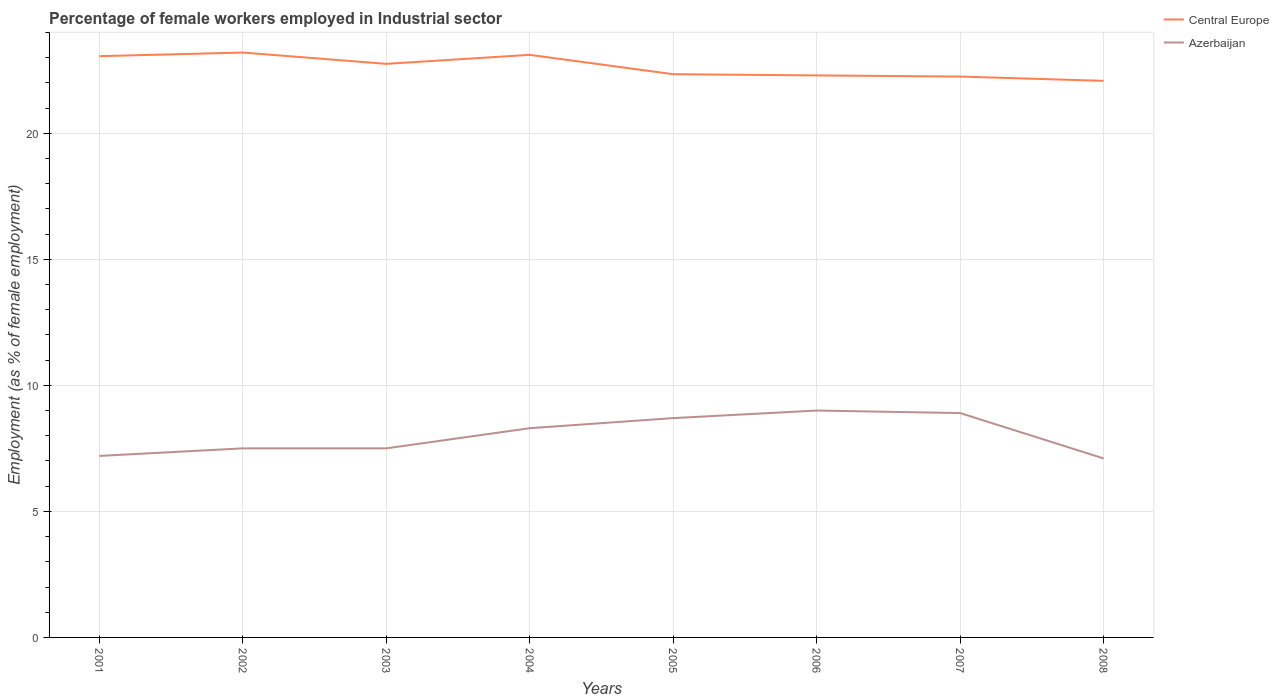How many different coloured lines are there?
Make the answer very short. 2. Does the line corresponding to Azerbaijan intersect with the line corresponding to Central Europe?
Keep it short and to the point. No. Is the number of lines equal to the number of legend labels?
Your answer should be compact. Yes. Across all years, what is the maximum percentage of females employed in Industrial sector in Azerbaijan?
Your response must be concise. 7.1. In which year was the percentage of females employed in Industrial sector in Central Europe maximum?
Offer a very short reply. 2008. What is the total percentage of females employed in Industrial sector in Central Europe in the graph?
Your answer should be very brief. 1.12. What is the difference between the highest and the second highest percentage of females employed in Industrial sector in Azerbaijan?
Offer a terse response. 1.9. What is the difference between the highest and the lowest percentage of females employed in Industrial sector in Central Europe?
Make the answer very short. 4. Is the percentage of females employed in Industrial sector in Azerbaijan strictly greater than the percentage of females employed in Industrial sector in Central Europe over the years?
Provide a succinct answer. Yes. Does the graph contain any zero values?
Offer a terse response. No. Does the graph contain grids?
Your response must be concise. Yes. Where does the legend appear in the graph?
Offer a very short reply. Top right. What is the title of the graph?
Offer a terse response. Percentage of female workers employed in Industrial sector. Does "Egypt, Arab Rep." appear as one of the legend labels in the graph?
Keep it short and to the point. No. What is the label or title of the X-axis?
Provide a short and direct response. Years. What is the label or title of the Y-axis?
Offer a very short reply. Employment (as % of female employment). What is the Employment (as % of female employment) in Central Europe in 2001?
Offer a very short reply. 23.06. What is the Employment (as % of female employment) in Azerbaijan in 2001?
Offer a very short reply. 7.2. What is the Employment (as % of female employment) of Central Europe in 2002?
Offer a very short reply. 23.2. What is the Employment (as % of female employment) of Azerbaijan in 2002?
Provide a short and direct response. 7.5. What is the Employment (as % of female employment) of Central Europe in 2003?
Make the answer very short. 22.75. What is the Employment (as % of female employment) in Central Europe in 2004?
Keep it short and to the point. 23.11. What is the Employment (as % of female employment) in Azerbaijan in 2004?
Make the answer very short. 8.3. What is the Employment (as % of female employment) in Central Europe in 2005?
Your answer should be very brief. 22.34. What is the Employment (as % of female employment) of Azerbaijan in 2005?
Your answer should be compact. 8.7. What is the Employment (as % of female employment) of Central Europe in 2006?
Your answer should be compact. 22.29. What is the Employment (as % of female employment) in Azerbaijan in 2006?
Give a very brief answer. 9. What is the Employment (as % of female employment) of Central Europe in 2007?
Provide a short and direct response. 22.25. What is the Employment (as % of female employment) of Azerbaijan in 2007?
Give a very brief answer. 8.9. What is the Employment (as % of female employment) of Central Europe in 2008?
Offer a very short reply. 22.08. What is the Employment (as % of female employment) in Azerbaijan in 2008?
Keep it short and to the point. 7.1. Across all years, what is the maximum Employment (as % of female employment) in Central Europe?
Offer a very short reply. 23.2. Across all years, what is the maximum Employment (as % of female employment) of Azerbaijan?
Provide a succinct answer. 9. Across all years, what is the minimum Employment (as % of female employment) of Central Europe?
Make the answer very short. 22.08. Across all years, what is the minimum Employment (as % of female employment) of Azerbaijan?
Offer a terse response. 7.1. What is the total Employment (as % of female employment) in Central Europe in the graph?
Keep it short and to the point. 181.08. What is the total Employment (as % of female employment) of Azerbaijan in the graph?
Offer a very short reply. 64.2. What is the difference between the Employment (as % of female employment) in Central Europe in 2001 and that in 2002?
Offer a very short reply. -0.14. What is the difference between the Employment (as % of female employment) of Central Europe in 2001 and that in 2003?
Provide a short and direct response. 0.3. What is the difference between the Employment (as % of female employment) of Central Europe in 2001 and that in 2004?
Offer a very short reply. -0.05. What is the difference between the Employment (as % of female employment) in Azerbaijan in 2001 and that in 2004?
Provide a short and direct response. -1.1. What is the difference between the Employment (as % of female employment) of Central Europe in 2001 and that in 2005?
Provide a succinct answer. 0.72. What is the difference between the Employment (as % of female employment) in Azerbaijan in 2001 and that in 2005?
Your answer should be very brief. -1.5. What is the difference between the Employment (as % of female employment) in Central Europe in 2001 and that in 2006?
Your answer should be very brief. 0.76. What is the difference between the Employment (as % of female employment) of Central Europe in 2001 and that in 2007?
Give a very brief answer. 0.81. What is the difference between the Employment (as % of female employment) in Azerbaijan in 2001 and that in 2007?
Make the answer very short. -1.7. What is the difference between the Employment (as % of female employment) in Azerbaijan in 2001 and that in 2008?
Give a very brief answer. 0.1. What is the difference between the Employment (as % of female employment) in Central Europe in 2002 and that in 2003?
Offer a very short reply. 0.45. What is the difference between the Employment (as % of female employment) in Azerbaijan in 2002 and that in 2003?
Give a very brief answer. 0. What is the difference between the Employment (as % of female employment) in Central Europe in 2002 and that in 2004?
Give a very brief answer. 0.09. What is the difference between the Employment (as % of female employment) of Azerbaijan in 2002 and that in 2004?
Offer a very short reply. -0.8. What is the difference between the Employment (as % of female employment) in Central Europe in 2002 and that in 2005?
Ensure brevity in your answer.  0.86. What is the difference between the Employment (as % of female employment) of Azerbaijan in 2002 and that in 2005?
Offer a terse response. -1.2. What is the difference between the Employment (as % of female employment) in Central Europe in 2002 and that in 2006?
Provide a short and direct response. 0.91. What is the difference between the Employment (as % of female employment) in Azerbaijan in 2002 and that in 2006?
Offer a very short reply. -1.5. What is the difference between the Employment (as % of female employment) in Central Europe in 2002 and that in 2007?
Provide a short and direct response. 0.95. What is the difference between the Employment (as % of female employment) in Central Europe in 2002 and that in 2008?
Your response must be concise. 1.12. What is the difference between the Employment (as % of female employment) in Central Europe in 2003 and that in 2004?
Your answer should be compact. -0.36. What is the difference between the Employment (as % of female employment) in Azerbaijan in 2003 and that in 2004?
Your answer should be compact. -0.8. What is the difference between the Employment (as % of female employment) of Central Europe in 2003 and that in 2005?
Provide a succinct answer. 0.41. What is the difference between the Employment (as % of female employment) in Azerbaijan in 2003 and that in 2005?
Provide a short and direct response. -1.2. What is the difference between the Employment (as % of female employment) in Central Europe in 2003 and that in 2006?
Provide a short and direct response. 0.46. What is the difference between the Employment (as % of female employment) of Azerbaijan in 2003 and that in 2006?
Provide a succinct answer. -1.5. What is the difference between the Employment (as % of female employment) in Central Europe in 2003 and that in 2007?
Provide a short and direct response. 0.5. What is the difference between the Employment (as % of female employment) of Azerbaijan in 2003 and that in 2007?
Your answer should be very brief. -1.4. What is the difference between the Employment (as % of female employment) in Central Europe in 2003 and that in 2008?
Offer a terse response. 0.68. What is the difference between the Employment (as % of female employment) of Central Europe in 2004 and that in 2005?
Offer a terse response. 0.77. What is the difference between the Employment (as % of female employment) of Central Europe in 2004 and that in 2006?
Provide a succinct answer. 0.82. What is the difference between the Employment (as % of female employment) of Central Europe in 2004 and that in 2007?
Your answer should be very brief. 0.86. What is the difference between the Employment (as % of female employment) of Azerbaijan in 2004 and that in 2007?
Keep it short and to the point. -0.6. What is the difference between the Employment (as % of female employment) in Central Europe in 2004 and that in 2008?
Your response must be concise. 1.03. What is the difference between the Employment (as % of female employment) of Central Europe in 2005 and that in 2006?
Ensure brevity in your answer.  0.05. What is the difference between the Employment (as % of female employment) of Central Europe in 2005 and that in 2007?
Make the answer very short. 0.09. What is the difference between the Employment (as % of female employment) in Azerbaijan in 2005 and that in 2007?
Give a very brief answer. -0.2. What is the difference between the Employment (as % of female employment) of Central Europe in 2005 and that in 2008?
Give a very brief answer. 0.26. What is the difference between the Employment (as % of female employment) in Central Europe in 2006 and that in 2007?
Your answer should be compact. 0.05. What is the difference between the Employment (as % of female employment) in Central Europe in 2006 and that in 2008?
Give a very brief answer. 0.22. What is the difference between the Employment (as % of female employment) of Central Europe in 2007 and that in 2008?
Give a very brief answer. 0.17. What is the difference between the Employment (as % of female employment) in Azerbaijan in 2007 and that in 2008?
Provide a succinct answer. 1.8. What is the difference between the Employment (as % of female employment) in Central Europe in 2001 and the Employment (as % of female employment) in Azerbaijan in 2002?
Your answer should be very brief. 15.56. What is the difference between the Employment (as % of female employment) in Central Europe in 2001 and the Employment (as % of female employment) in Azerbaijan in 2003?
Keep it short and to the point. 15.56. What is the difference between the Employment (as % of female employment) in Central Europe in 2001 and the Employment (as % of female employment) in Azerbaijan in 2004?
Make the answer very short. 14.76. What is the difference between the Employment (as % of female employment) of Central Europe in 2001 and the Employment (as % of female employment) of Azerbaijan in 2005?
Provide a short and direct response. 14.36. What is the difference between the Employment (as % of female employment) in Central Europe in 2001 and the Employment (as % of female employment) in Azerbaijan in 2006?
Keep it short and to the point. 14.06. What is the difference between the Employment (as % of female employment) in Central Europe in 2001 and the Employment (as % of female employment) in Azerbaijan in 2007?
Make the answer very short. 14.16. What is the difference between the Employment (as % of female employment) of Central Europe in 2001 and the Employment (as % of female employment) of Azerbaijan in 2008?
Keep it short and to the point. 15.96. What is the difference between the Employment (as % of female employment) of Central Europe in 2002 and the Employment (as % of female employment) of Azerbaijan in 2003?
Your answer should be very brief. 15.7. What is the difference between the Employment (as % of female employment) of Central Europe in 2002 and the Employment (as % of female employment) of Azerbaijan in 2004?
Keep it short and to the point. 14.9. What is the difference between the Employment (as % of female employment) of Central Europe in 2002 and the Employment (as % of female employment) of Azerbaijan in 2005?
Offer a very short reply. 14.5. What is the difference between the Employment (as % of female employment) in Central Europe in 2002 and the Employment (as % of female employment) in Azerbaijan in 2006?
Provide a short and direct response. 14.2. What is the difference between the Employment (as % of female employment) in Central Europe in 2002 and the Employment (as % of female employment) in Azerbaijan in 2007?
Provide a succinct answer. 14.3. What is the difference between the Employment (as % of female employment) of Central Europe in 2002 and the Employment (as % of female employment) of Azerbaijan in 2008?
Your answer should be very brief. 16.1. What is the difference between the Employment (as % of female employment) in Central Europe in 2003 and the Employment (as % of female employment) in Azerbaijan in 2004?
Provide a succinct answer. 14.45. What is the difference between the Employment (as % of female employment) of Central Europe in 2003 and the Employment (as % of female employment) of Azerbaijan in 2005?
Offer a very short reply. 14.05. What is the difference between the Employment (as % of female employment) of Central Europe in 2003 and the Employment (as % of female employment) of Azerbaijan in 2006?
Make the answer very short. 13.75. What is the difference between the Employment (as % of female employment) of Central Europe in 2003 and the Employment (as % of female employment) of Azerbaijan in 2007?
Your answer should be compact. 13.85. What is the difference between the Employment (as % of female employment) in Central Europe in 2003 and the Employment (as % of female employment) in Azerbaijan in 2008?
Your answer should be compact. 15.65. What is the difference between the Employment (as % of female employment) in Central Europe in 2004 and the Employment (as % of female employment) in Azerbaijan in 2005?
Provide a succinct answer. 14.41. What is the difference between the Employment (as % of female employment) in Central Europe in 2004 and the Employment (as % of female employment) in Azerbaijan in 2006?
Your response must be concise. 14.11. What is the difference between the Employment (as % of female employment) of Central Europe in 2004 and the Employment (as % of female employment) of Azerbaijan in 2007?
Your answer should be compact. 14.21. What is the difference between the Employment (as % of female employment) in Central Europe in 2004 and the Employment (as % of female employment) in Azerbaijan in 2008?
Offer a very short reply. 16.01. What is the difference between the Employment (as % of female employment) of Central Europe in 2005 and the Employment (as % of female employment) of Azerbaijan in 2006?
Provide a short and direct response. 13.34. What is the difference between the Employment (as % of female employment) in Central Europe in 2005 and the Employment (as % of female employment) in Azerbaijan in 2007?
Your response must be concise. 13.44. What is the difference between the Employment (as % of female employment) of Central Europe in 2005 and the Employment (as % of female employment) of Azerbaijan in 2008?
Keep it short and to the point. 15.24. What is the difference between the Employment (as % of female employment) in Central Europe in 2006 and the Employment (as % of female employment) in Azerbaijan in 2007?
Keep it short and to the point. 13.39. What is the difference between the Employment (as % of female employment) in Central Europe in 2006 and the Employment (as % of female employment) in Azerbaijan in 2008?
Offer a terse response. 15.19. What is the difference between the Employment (as % of female employment) in Central Europe in 2007 and the Employment (as % of female employment) in Azerbaijan in 2008?
Offer a very short reply. 15.15. What is the average Employment (as % of female employment) of Central Europe per year?
Provide a succinct answer. 22.64. What is the average Employment (as % of female employment) of Azerbaijan per year?
Keep it short and to the point. 8.03. In the year 2001, what is the difference between the Employment (as % of female employment) of Central Europe and Employment (as % of female employment) of Azerbaijan?
Give a very brief answer. 15.86. In the year 2002, what is the difference between the Employment (as % of female employment) of Central Europe and Employment (as % of female employment) of Azerbaijan?
Your response must be concise. 15.7. In the year 2003, what is the difference between the Employment (as % of female employment) of Central Europe and Employment (as % of female employment) of Azerbaijan?
Offer a very short reply. 15.25. In the year 2004, what is the difference between the Employment (as % of female employment) of Central Europe and Employment (as % of female employment) of Azerbaijan?
Offer a terse response. 14.81. In the year 2005, what is the difference between the Employment (as % of female employment) in Central Europe and Employment (as % of female employment) in Azerbaijan?
Make the answer very short. 13.64. In the year 2006, what is the difference between the Employment (as % of female employment) of Central Europe and Employment (as % of female employment) of Azerbaijan?
Your answer should be very brief. 13.29. In the year 2007, what is the difference between the Employment (as % of female employment) of Central Europe and Employment (as % of female employment) of Azerbaijan?
Provide a succinct answer. 13.35. In the year 2008, what is the difference between the Employment (as % of female employment) of Central Europe and Employment (as % of female employment) of Azerbaijan?
Offer a very short reply. 14.98. What is the ratio of the Employment (as % of female employment) of Central Europe in 2001 to that in 2003?
Your response must be concise. 1.01. What is the ratio of the Employment (as % of female employment) in Azerbaijan in 2001 to that in 2004?
Your answer should be compact. 0.87. What is the ratio of the Employment (as % of female employment) in Central Europe in 2001 to that in 2005?
Offer a very short reply. 1.03. What is the ratio of the Employment (as % of female employment) in Azerbaijan in 2001 to that in 2005?
Your response must be concise. 0.83. What is the ratio of the Employment (as % of female employment) of Central Europe in 2001 to that in 2006?
Your answer should be very brief. 1.03. What is the ratio of the Employment (as % of female employment) in Central Europe in 2001 to that in 2007?
Your response must be concise. 1.04. What is the ratio of the Employment (as % of female employment) in Azerbaijan in 2001 to that in 2007?
Offer a terse response. 0.81. What is the ratio of the Employment (as % of female employment) in Central Europe in 2001 to that in 2008?
Keep it short and to the point. 1.04. What is the ratio of the Employment (as % of female employment) of Azerbaijan in 2001 to that in 2008?
Ensure brevity in your answer.  1.01. What is the ratio of the Employment (as % of female employment) of Central Europe in 2002 to that in 2003?
Your response must be concise. 1.02. What is the ratio of the Employment (as % of female employment) in Azerbaijan in 2002 to that in 2004?
Offer a terse response. 0.9. What is the ratio of the Employment (as % of female employment) of Central Europe in 2002 to that in 2005?
Offer a very short reply. 1.04. What is the ratio of the Employment (as % of female employment) in Azerbaijan in 2002 to that in 2005?
Make the answer very short. 0.86. What is the ratio of the Employment (as % of female employment) of Central Europe in 2002 to that in 2006?
Offer a terse response. 1.04. What is the ratio of the Employment (as % of female employment) of Azerbaijan in 2002 to that in 2006?
Ensure brevity in your answer.  0.83. What is the ratio of the Employment (as % of female employment) in Central Europe in 2002 to that in 2007?
Give a very brief answer. 1.04. What is the ratio of the Employment (as % of female employment) of Azerbaijan in 2002 to that in 2007?
Make the answer very short. 0.84. What is the ratio of the Employment (as % of female employment) of Central Europe in 2002 to that in 2008?
Offer a terse response. 1.05. What is the ratio of the Employment (as % of female employment) in Azerbaijan in 2002 to that in 2008?
Keep it short and to the point. 1.06. What is the ratio of the Employment (as % of female employment) of Central Europe in 2003 to that in 2004?
Offer a terse response. 0.98. What is the ratio of the Employment (as % of female employment) of Azerbaijan in 2003 to that in 2004?
Offer a very short reply. 0.9. What is the ratio of the Employment (as % of female employment) in Central Europe in 2003 to that in 2005?
Give a very brief answer. 1.02. What is the ratio of the Employment (as % of female employment) in Azerbaijan in 2003 to that in 2005?
Give a very brief answer. 0.86. What is the ratio of the Employment (as % of female employment) of Central Europe in 2003 to that in 2006?
Provide a succinct answer. 1.02. What is the ratio of the Employment (as % of female employment) of Central Europe in 2003 to that in 2007?
Offer a very short reply. 1.02. What is the ratio of the Employment (as % of female employment) in Azerbaijan in 2003 to that in 2007?
Provide a succinct answer. 0.84. What is the ratio of the Employment (as % of female employment) of Central Europe in 2003 to that in 2008?
Ensure brevity in your answer.  1.03. What is the ratio of the Employment (as % of female employment) in Azerbaijan in 2003 to that in 2008?
Offer a very short reply. 1.06. What is the ratio of the Employment (as % of female employment) of Central Europe in 2004 to that in 2005?
Ensure brevity in your answer.  1.03. What is the ratio of the Employment (as % of female employment) of Azerbaijan in 2004 to that in 2005?
Keep it short and to the point. 0.95. What is the ratio of the Employment (as % of female employment) of Central Europe in 2004 to that in 2006?
Offer a terse response. 1.04. What is the ratio of the Employment (as % of female employment) in Azerbaijan in 2004 to that in 2006?
Your answer should be very brief. 0.92. What is the ratio of the Employment (as % of female employment) of Central Europe in 2004 to that in 2007?
Provide a succinct answer. 1.04. What is the ratio of the Employment (as % of female employment) of Azerbaijan in 2004 to that in 2007?
Make the answer very short. 0.93. What is the ratio of the Employment (as % of female employment) of Central Europe in 2004 to that in 2008?
Offer a very short reply. 1.05. What is the ratio of the Employment (as % of female employment) of Azerbaijan in 2004 to that in 2008?
Your response must be concise. 1.17. What is the ratio of the Employment (as % of female employment) in Azerbaijan in 2005 to that in 2006?
Provide a succinct answer. 0.97. What is the ratio of the Employment (as % of female employment) in Central Europe in 2005 to that in 2007?
Offer a terse response. 1. What is the ratio of the Employment (as % of female employment) in Azerbaijan in 2005 to that in 2007?
Your response must be concise. 0.98. What is the ratio of the Employment (as % of female employment) in Central Europe in 2005 to that in 2008?
Your response must be concise. 1.01. What is the ratio of the Employment (as % of female employment) in Azerbaijan in 2005 to that in 2008?
Your answer should be very brief. 1.23. What is the ratio of the Employment (as % of female employment) in Azerbaijan in 2006 to that in 2007?
Your response must be concise. 1.01. What is the ratio of the Employment (as % of female employment) of Central Europe in 2006 to that in 2008?
Keep it short and to the point. 1.01. What is the ratio of the Employment (as % of female employment) in Azerbaijan in 2006 to that in 2008?
Give a very brief answer. 1.27. What is the ratio of the Employment (as % of female employment) of Central Europe in 2007 to that in 2008?
Offer a terse response. 1.01. What is the ratio of the Employment (as % of female employment) of Azerbaijan in 2007 to that in 2008?
Your response must be concise. 1.25. What is the difference between the highest and the second highest Employment (as % of female employment) of Central Europe?
Your answer should be very brief. 0.09. What is the difference between the highest and the second highest Employment (as % of female employment) of Azerbaijan?
Ensure brevity in your answer.  0.1. What is the difference between the highest and the lowest Employment (as % of female employment) in Central Europe?
Offer a very short reply. 1.12. 